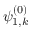<formula> <loc_0><loc_0><loc_500><loc_500>\psi _ { 1 , k } ^ { ( 0 ) }</formula> 